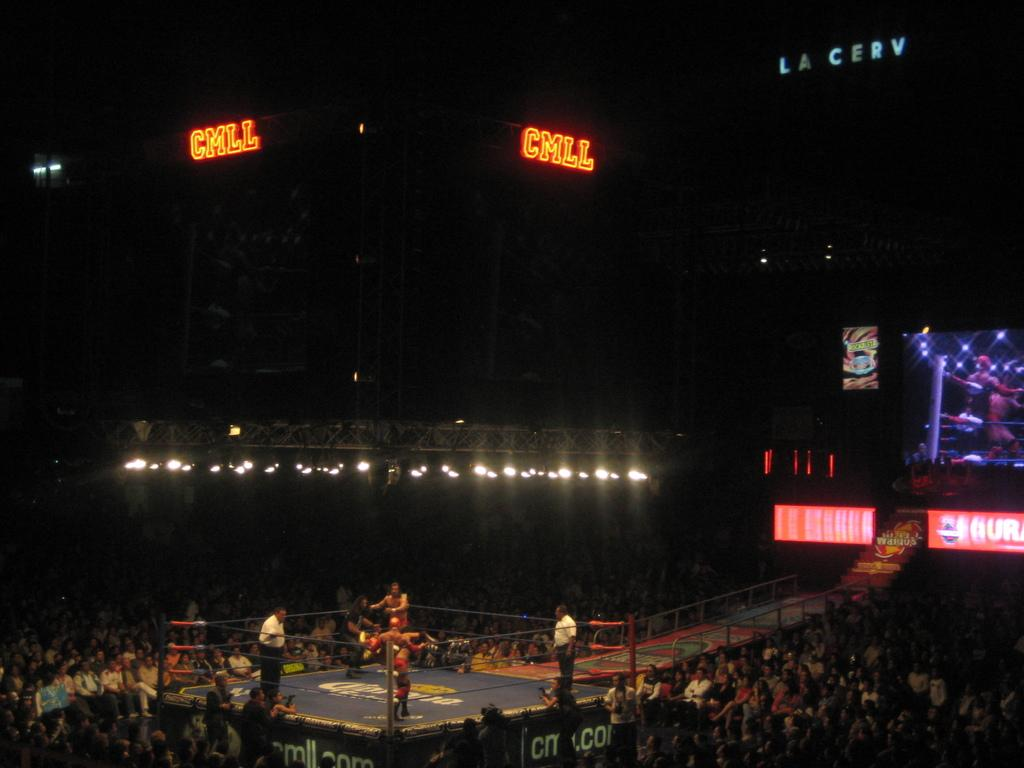<image>
Offer a succinct explanation of the picture presented. Boxing arena with a light that says the letters CMLL on the roof. 